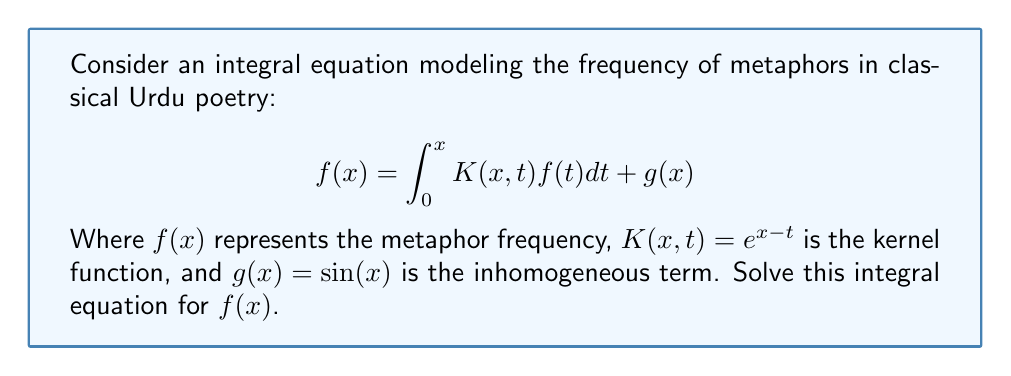Provide a solution to this math problem. To solve this integral equation, we'll follow these steps:

1) First, we differentiate both sides of the equation with respect to x:
   $$f'(x) = K(x,x)f(x) + \int_0^x \frac{\partial K(x,t)}{\partial x}f(t)dt + g'(x)$$

2) Substitute the given kernel function $K(x,t) = e^{x-t}$:
   $$f'(x) = e^{x-x}f(x) + \int_0^x e^{x-t}f(t)dt + \cos(x)$$

3) Simplify:
   $$f'(x) = f(x) + \int_0^x e^{x-t}f(t)dt + \cos(x)$$

4) Now, subtract the original equation from this new equation:
   $$f'(x) - f(x) = \cos(x) - \sin(x)$$

5) This is a first-order linear differential equation. We can solve it using the integrating factor method. The integrating factor is $e^{-x}$.

6) Multiply both sides by $e^{-x}$:
   $$e^{-x}f'(x) - e^{-x}f(x) = e^{-x}\cos(x) - e^{-x}\sin(x)$$

7) The left side is now the derivative of $e^{-x}f(x)$. Integrate both sides:
   $$e^{-x}f(x) = \int (e^{-x}\cos(x) - e^{-x}\sin(x)) dx + C$$

8) Solving the integral:
   $$e^{-x}f(x) = -\frac{1}{2}e^{-x}(\sin(x) + \cos(x)) + C$$

9) Multiply both sides by $e^x$:
   $$f(x) = -\frac{1}{2}(\sin(x) + \cos(x)) + Ce^x$$

10) To find C, use the initial condition $f(0) = g(0) = \sin(0) = 0$:
    $$0 = -\frac{1}{2}(\sin(0) + \cos(0)) + C$$
    $$C = \frac{1}{2}$$

11) Therefore, the final solution is:
    $$f(x) = -\frac{1}{2}(\sin(x) + \cos(x)) + \frac{1}{2}e^x$$
Answer: $f(x) = -\frac{1}{2}(\sin(x) + \cos(x)) + \frac{1}{2}e^x$ 